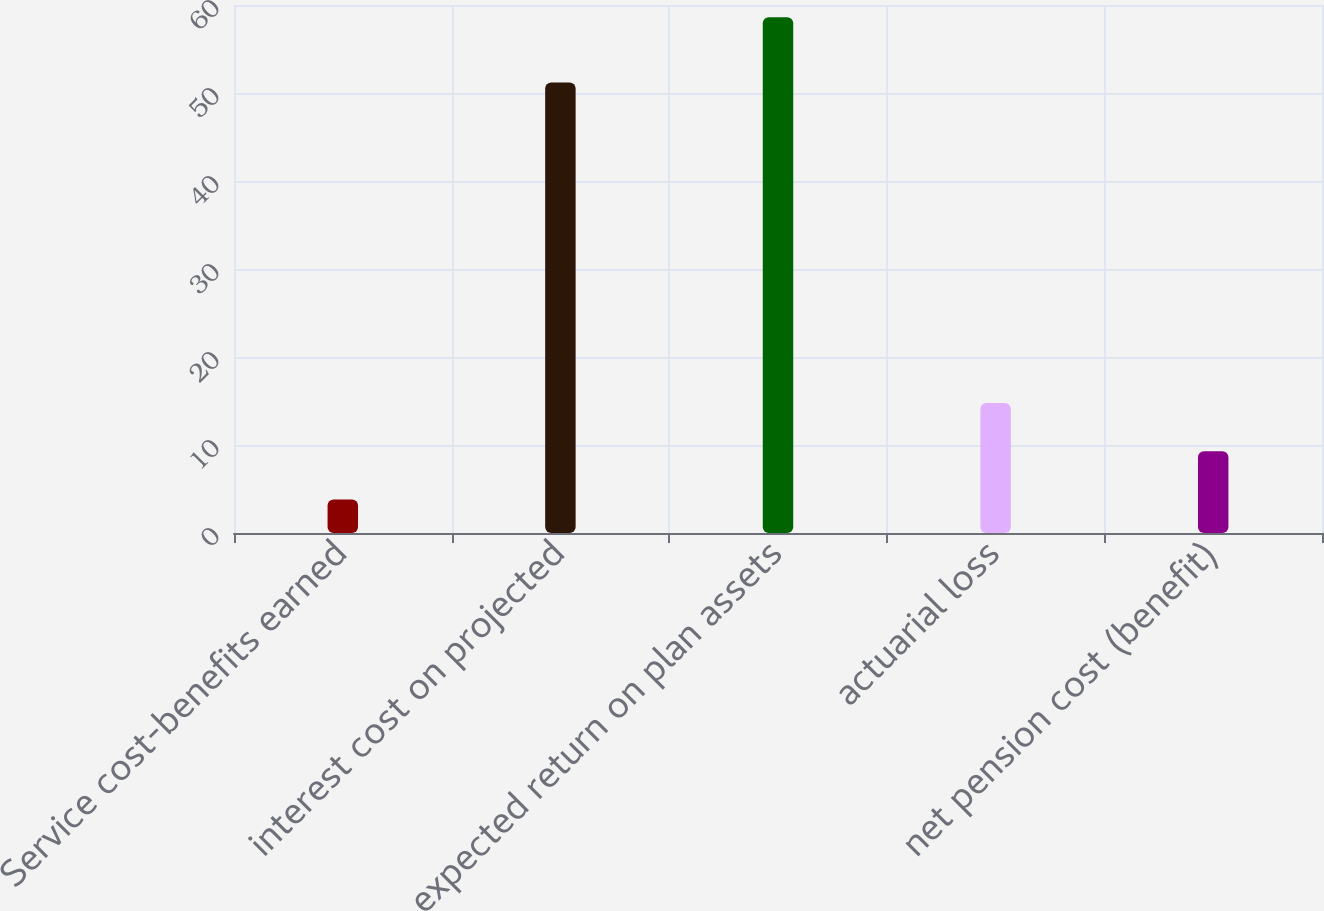Convert chart to OTSL. <chart><loc_0><loc_0><loc_500><loc_500><bar_chart><fcel>Service cost-benefits earned<fcel>interest cost on projected<fcel>expected return on plan assets<fcel>actuarial loss<fcel>net pension cost (benefit)<nl><fcel>3.8<fcel>51.2<fcel>58.6<fcel>14.76<fcel>9.28<nl></chart> 